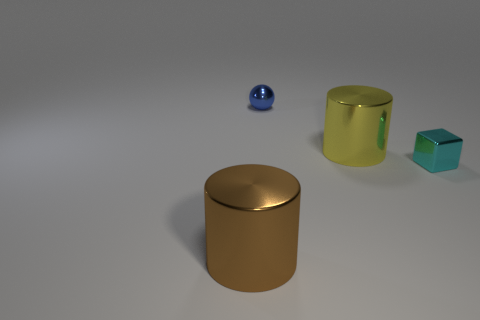Is there any other thing that has the same shape as the cyan metallic object?
Offer a terse response. No. Does the metal cube have the same size as the yellow metallic thing?
Keep it short and to the point. No. There is a shiny cylinder that is to the right of the large thing that is in front of the large yellow cylinder; how big is it?
Give a very brief answer. Large. What number of cubes are blue objects or blue matte objects?
Ensure brevity in your answer.  0. Is the size of the cube the same as the thing that is in front of the small cyan shiny thing?
Provide a short and direct response. No. Is the number of tiny cubes on the left side of the cyan object greater than the number of shiny cylinders?
Give a very brief answer. No. What size is the brown cylinder that is made of the same material as the small cube?
Provide a short and direct response. Large. Are there any small metal spheres that have the same color as the metal block?
Give a very brief answer. No. What number of things are either tiny blue objects or large shiny objects in front of the shiny cube?
Your response must be concise. 2. Are there more small blue metal objects than tiny blue matte balls?
Give a very brief answer. Yes. 